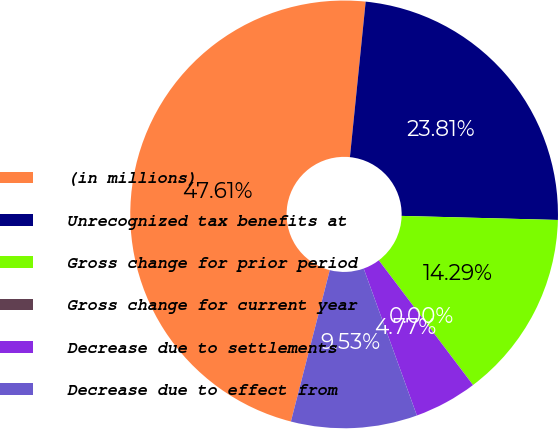<chart> <loc_0><loc_0><loc_500><loc_500><pie_chart><fcel>(in millions)<fcel>Unrecognized tax benefits at<fcel>Gross change for prior period<fcel>Gross change for current year<fcel>Decrease due to settlements<fcel>Decrease due to effect from<nl><fcel>47.61%<fcel>23.81%<fcel>14.29%<fcel>0.0%<fcel>4.77%<fcel>9.53%<nl></chart> 